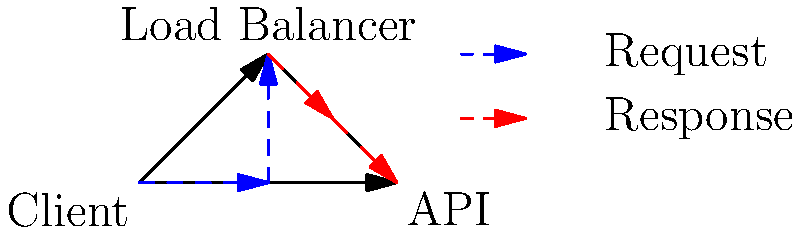In the given network packet flow diagram for API testing, what potential issue could arise if the load balancer is not properly configured, and how might this affect the test results? To analyze the potential issues in this network packet flow diagram for API testing, let's follow these steps:

1. Understand the diagram:
   - The client sends requests to the API through a load balancer.
   - The load balancer distributes incoming requests to the API.
   - The API sends responses back through the load balancer to the client.

2. Identify the role of the load balancer:
   - It's meant to distribute traffic evenly across multiple API instances (not shown in the diagram).
   - It should ensure high availability and optimal performance.

3. Consider potential misconfiguration issues:
   - Uneven distribution of requests
   - Improper health checks
   - Incorrect session persistence settings

4. Analyze the impact on test results:
   - Uneven distribution could lead to:
     a) Inconsistent response times
     b) Some API instances being overloaded while others are underutilized
   - Improper health checks might result in:
     a) Requests being sent to non-responsive API instances
     b) False positives or negatives in availability tests
   - Incorrect session persistence could cause:
     a) Stateful operations failing due to requests being routed to different instances
     b) Inconsistent test results for user session-based scenarios

5. Focus on the main issue:
   - The most significant problem would be inconsistent test results due to uneven request distribution.

6. Conclude the impact:
   - This would lead to unreliable performance metrics and potentially mask real API issues.
Answer: Inconsistent test results due to uneven request distribution, leading to unreliable performance metrics 